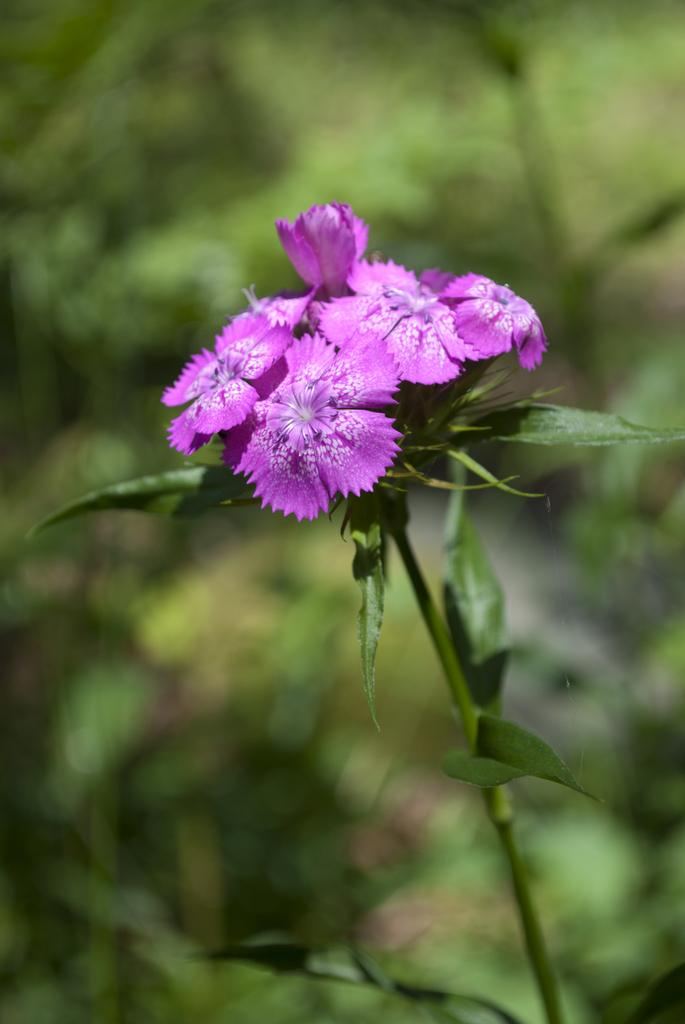What is the main subject of the image? The main subject of the image is flowers. Where are the flowers located? The flowers are on a plant in the center of the image. What can be seen in the background of the image? There is greenery in the background of the image. What type of floor can be seen beneath the flowers in the image? There is no floor visible in the image; it only shows flowers on a plant and greenery in the background. 